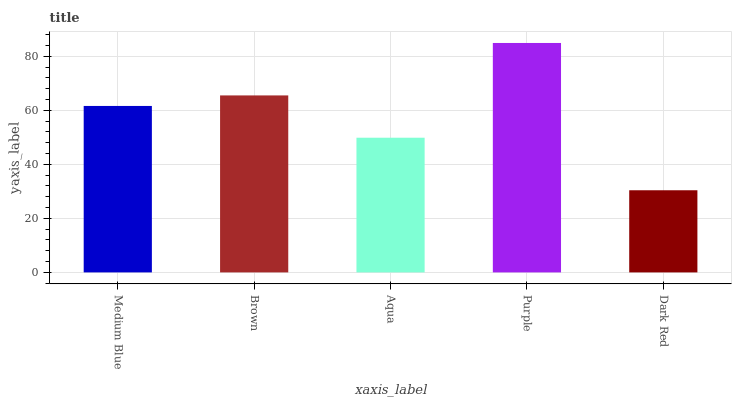Is Dark Red the minimum?
Answer yes or no. Yes. Is Purple the maximum?
Answer yes or no. Yes. Is Brown the minimum?
Answer yes or no. No. Is Brown the maximum?
Answer yes or no. No. Is Brown greater than Medium Blue?
Answer yes or no. Yes. Is Medium Blue less than Brown?
Answer yes or no. Yes. Is Medium Blue greater than Brown?
Answer yes or no. No. Is Brown less than Medium Blue?
Answer yes or no. No. Is Medium Blue the high median?
Answer yes or no. Yes. Is Medium Blue the low median?
Answer yes or no. Yes. Is Purple the high median?
Answer yes or no. No. Is Brown the low median?
Answer yes or no. No. 